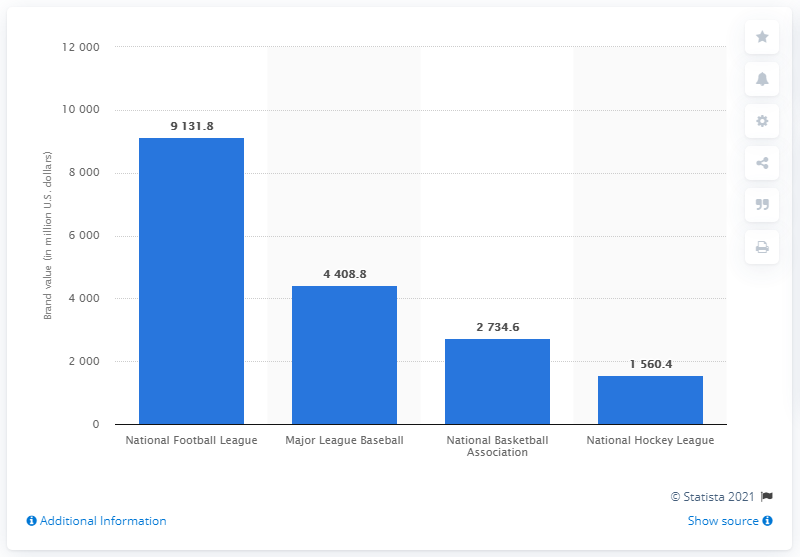Specify some key components in this picture. The combined brand value of the National Football League in 2013 was 91,318. 